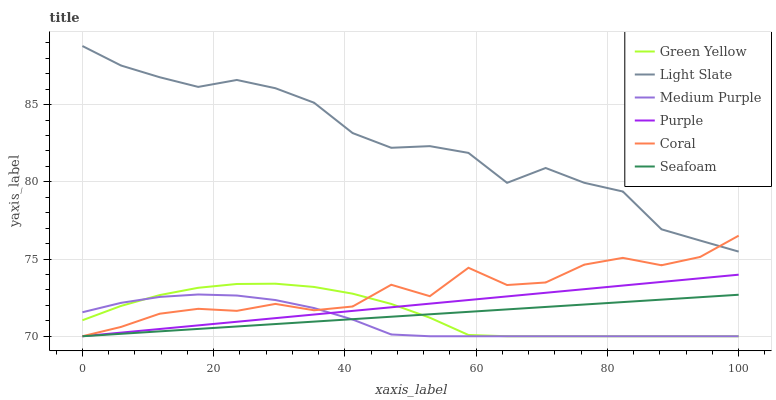Does Medium Purple have the minimum area under the curve?
Answer yes or no. Yes. Does Light Slate have the maximum area under the curve?
Answer yes or no. Yes. Does Coral have the minimum area under the curve?
Answer yes or no. No. Does Coral have the maximum area under the curve?
Answer yes or no. No. Is Purple the smoothest?
Answer yes or no. Yes. Is Coral the roughest?
Answer yes or no. Yes. Is Seafoam the smoothest?
Answer yes or no. No. Is Seafoam the roughest?
Answer yes or no. No. Does Coral have the lowest value?
Answer yes or no. Yes. Does Light Slate have the highest value?
Answer yes or no. Yes. Does Coral have the highest value?
Answer yes or no. No. Is Seafoam less than Light Slate?
Answer yes or no. Yes. Is Light Slate greater than Medium Purple?
Answer yes or no. Yes. Does Green Yellow intersect Coral?
Answer yes or no. Yes. Is Green Yellow less than Coral?
Answer yes or no. No. Is Green Yellow greater than Coral?
Answer yes or no. No. Does Seafoam intersect Light Slate?
Answer yes or no. No. 